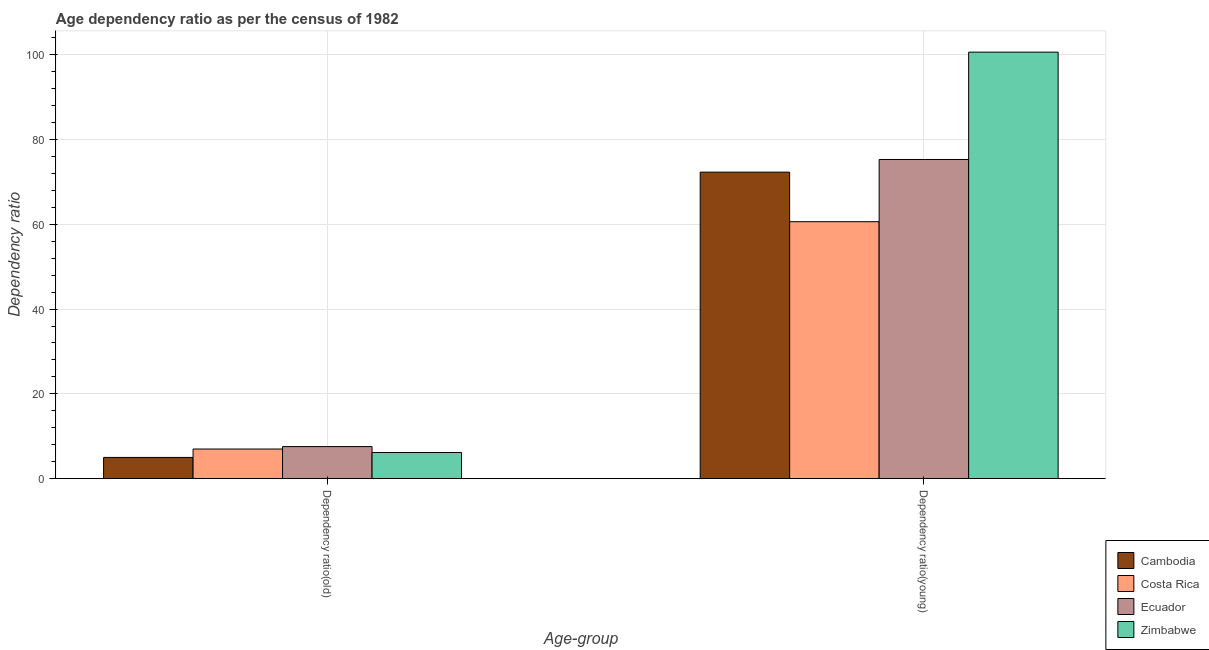How many bars are there on the 2nd tick from the right?
Keep it short and to the point. 4. What is the label of the 2nd group of bars from the left?
Your answer should be compact. Dependency ratio(young). What is the age dependency ratio(old) in Ecuador?
Provide a succinct answer. 7.55. Across all countries, what is the maximum age dependency ratio(old)?
Provide a short and direct response. 7.55. Across all countries, what is the minimum age dependency ratio(young)?
Ensure brevity in your answer.  60.62. In which country was the age dependency ratio(young) maximum?
Your answer should be compact. Zimbabwe. In which country was the age dependency ratio(old) minimum?
Provide a short and direct response. Cambodia. What is the total age dependency ratio(young) in the graph?
Your response must be concise. 308.84. What is the difference between the age dependency ratio(old) in Cambodia and that in Ecuador?
Offer a very short reply. -2.55. What is the difference between the age dependency ratio(old) in Costa Rica and the age dependency ratio(young) in Ecuador?
Provide a short and direct response. -68.31. What is the average age dependency ratio(young) per country?
Offer a very short reply. 77.21. What is the difference between the age dependency ratio(young) and age dependency ratio(old) in Costa Rica?
Provide a succinct answer. 53.64. What is the ratio of the age dependency ratio(old) in Costa Rica to that in Cambodia?
Make the answer very short. 1.4. Is the age dependency ratio(young) in Cambodia less than that in Zimbabwe?
Your answer should be very brief. Yes. What does the 3rd bar from the left in Dependency ratio(old) represents?
Give a very brief answer. Ecuador. What does the 2nd bar from the right in Dependency ratio(old) represents?
Your answer should be compact. Ecuador. How many bars are there?
Your answer should be compact. 8. Are all the bars in the graph horizontal?
Your answer should be very brief. No. How many countries are there in the graph?
Ensure brevity in your answer.  4. Does the graph contain grids?
Provide a succinct answer. Yes. How many legend labels are there?
Ensure brevity in your answer.  4. What is the title of the graph?
Ensure brevity in your answer.  Age dependency ratio as per the census of 1982. What is the label or title of the X-axis?
Your response must be concise. Age-group. What is the label or title of the Y-axis?
Keep it short and to the point. Dependency ratio. What is the Dependency ratio in Cambodia in Dependency ratio(old)?
Offer a very short reply. 5. What is the Dependency ratio in Costa Rica in Dependency ratio(old)?
Your answer should be very brief. 6.98. What is the Dependency ratio of Ecuador in Dependency ratio(old)?
Offer a terse response. 7.55. What is the Dependency ratio of Zimbabwe in Dependency ratio(old)?
Provide a succinct answer. 6.16. What is the Dependency ratio of Cambodia in Dependency ratio(young)?
Provide a succinct answer. 72.31. What is the Dependency ratio of Costa Rica in Dependency ratio(young)?
Your answer should be very brief. 60.62. What is the Dependency ratio of Ecuador in Dependency ratio(young)?
Keep it short and to the point. 75.29. What is the Dependency ratio of Zimbabwe in Dependency ratio(young)?
Keep it short and to the point. 100.62. Across all Age-group, what is the maximum Dependency ratio of Cambodia?
Make the answer very short. 72.31. Across all Age-group, what is the maximum Dependency ratio in Costa Rica?
Your answer should be compact. 60.62. Across all Age-group, what is the maximum Dependency ratio in Ecuador?
Your response must be concise. 75.29. Across all Age-group, what is the maximum Dependency ratio of Zimbabwe?
Offer a very short reply. 100.62. Across all Age-group, what is the minimum Dependency ratio of Cambodia?
Provide a succinct answer. 5. Across all Age-group, what is the minimum Dependency ratio in Costa Rica?
Provide a short and direct response. 6.98. Across all Age-group, what is the minimum Dependency ratio in Ecuador?
Provide a short and direct response. 7.55. Across all Age-group, what is the minimum Dependency ratio in Zimbabwe?
Provide a succinct answer. 6.16. What is the total Dependency ratio of Cambodia in the graph?
Keep it short and to the point. 77.31. What is the total Dependency ratio of Costa Rica in the graph?
Provide a short and direct response. 67.6. What is the total Dependency ratio of Ecuador in the graph?
Your answer should be very brief. 82.85. What is the total Dependency ratio of Zimbabwe in the graph?
Provide a succinct answer. 106.78. What is the difference between the Dependency ratio of Cambodia in Dependency ratio(old) and that in Dependency ratio(young)?
Offer a very short reply. -67.31. What is the difference between the Dependency ratio in Costa Rica in Dependency ratio(old) and that in Dependency ratio(young)?
Your response must be concise. -53.64. What is the difference between the Dependency ratio in Ecuador in Dependency ratio(old) and that in Dependency ratio(young)?
Make the answer very short. -67.74. What is the difference between the Dependency ratio in Zimbabwe in Dependency ratio(old) and that in Dependency ratio(young)?
Your answer should be compact. -94.46. What is the difference between the Dependency ratio of Cambodia in Dependency ratio(old) and the Dependency ratio of Costa Rica in Dependency ratio(young)?
Make the answer very short. -55.62. What is the difference between the Dependency ratio in Cambodia in Dependency ratio(old) and the Dependency ratio in Ecuador in Dependency ratio(young)?
Make the answer very short. -70.29. What is the difference between the Dependency ratio in Cambodia in Dependency ratio(old) and the Dependency ratio in Zimbabwe in Dependency ratio(young)?
Give a very brief answer. -95.62. What is the difference between the Dependency ratio of Costa Rica in Dependency ratio(old) and the Dependency ratio of Ecuador in Dependency ratio(young)?
Give a very brief answer. -68.31. What is the difference between the Dependency ratio of Costa Rica in Dependency ratio(old) and the Dependency ratio of Zimbabwe in Dependency ratio(young)?
Provide a short and direct response. -93.64. What is the difference between the Dependency ratio in Ecuador in Dependency ratio(old) and the Dependency ratio in Zimbabwe in Dependency ratio(young)?
Ensure brevity in your answer.  -93.07. What is the average Dependency ratio in Cambodia per Age-group?
Your response must be concise. 38.65. What is the average Dependency ratio in Costa Rica per Age-group?
Offer a terse response. 33.8. What is the average Dependency ratio of Ecuador per Age-group?
Make the answer very short. 41.42. What is the average Dependency ratio in Zimbabwe per Age-group?
Offer a terse response. 53.39. What is the difference between the Dependency ratio of Cambodia and Dependency ratio of Costa Rica in Dependency ratio(old)?
Offer a very short reply. -1.98. What is the difference between the Dependency ratio in Cambodia and Dependency ratio in Ecuador in Dependency ratio(old)?
Your answer should be compact. -2.56. What is the difference between the Dependency ratio of Cambodia and Dependency ratio of Zimbabwe in Dependency ratio(old)?
Provide a succinct answer. -1.16. What is the difference between the Dependency ratio of Costa Rica and Dependency ratio of Ecuador in Dependency ratio(old)?
Your answer should be very brief. -0.57. What is the difference between the Dependency ratio in Costa Rica and Dependency ratio in Zimbabwe in Dependency ratio(old)?
Keep it short and to the point. 0.82. What is the difference between the Dependency ratio of Ecuador and Dependency ratio of Zimbabwe in Dependency ratio(old)?
Your response must be concise. 1.39. What is the difference between the Dependency ratio of Cambodia and Dependency ratio of Costa Rica in Dependency ratio(young)?
Offer a terse response. 11.69. What is the difference between the Dependency ratio of Cambodia and Dependency ratio of Ecuador in Dependency ratio(young)?
Keep it short and to the point. -2.98. What is the difference between the Dependency ratio of Cambodia and Dependency ratio of Zimbabwe in Dependency ratio(young)?
Ensure brevity in your answer.  -28.31. What is the difference between the Dependency ratio of Costa Rica and Dependency ratio of Ecuador in Dependency ratio(young)?
Offer a very short reply. -14.68. What is the difference between the Dependency ratio in Costa Rica and Dependency ratio in Zimbabwe in Dependency ratio(young)?
Offer a terse response. -40. What is the difference between the Dependency ratio of Ecuador and Dependency ratio of Zimbabwe in Dependency ratio(young)?
Offer a very short reply. -25.33. What is the ratio of the Dependency ratio of Cambodia in Dependency ratio(old) to that in Dependency ratio(young)?
Keep it short and to the point. 0.07. What is the ratio of the Dependency ratio in Costa Rica in Dependency ratio(old) to that in Dependency ratio(young)?
Your answer should be very brief. 0.12. What is the ratio of the Dependency ratio of Ecuador in Dependency ratio(old) to that in Dependency ratio(young)?
Offer a terse response. 0.1. What is the ratio of the Dependency ratio in Zimbabwe in Dependency ratio(old) to that in Dependency ratio(young)?
Your answer should be very brief. 0.06. What is the difference between the highest and the second highest Dependency ratio of Cambodia?
Offer a very short reply. 67.31. What is the difference between the highest and the second highest Dependency ratio of Costa Rica?
Provide a succinct answer. 53.64. What is the difference between the highest and the second highest Dependency ratio of Ecuador?
Provide a short and direct response. 67.74. What is the difference between the highest and the second highest Dependency ratio of Zimbabwe?
Ensure brevity in your answer.  94.46. What is the difference between the highest and the lowest Dependency ratio of Cambodia?
Give a very brief answer. 67.31. What is the difference between the highest and the lowest Dependency ratio in Costa Rica?
Your answer should be very brief. 53.64. What is the difference between the highest and the lowest Dependency ratio in Ecuador?
Your answer should be compact. 67.74. What is the difference between the highest and the lowest Dependency ratio in Zimbabwe?
Offer a terse response. 94.46. 